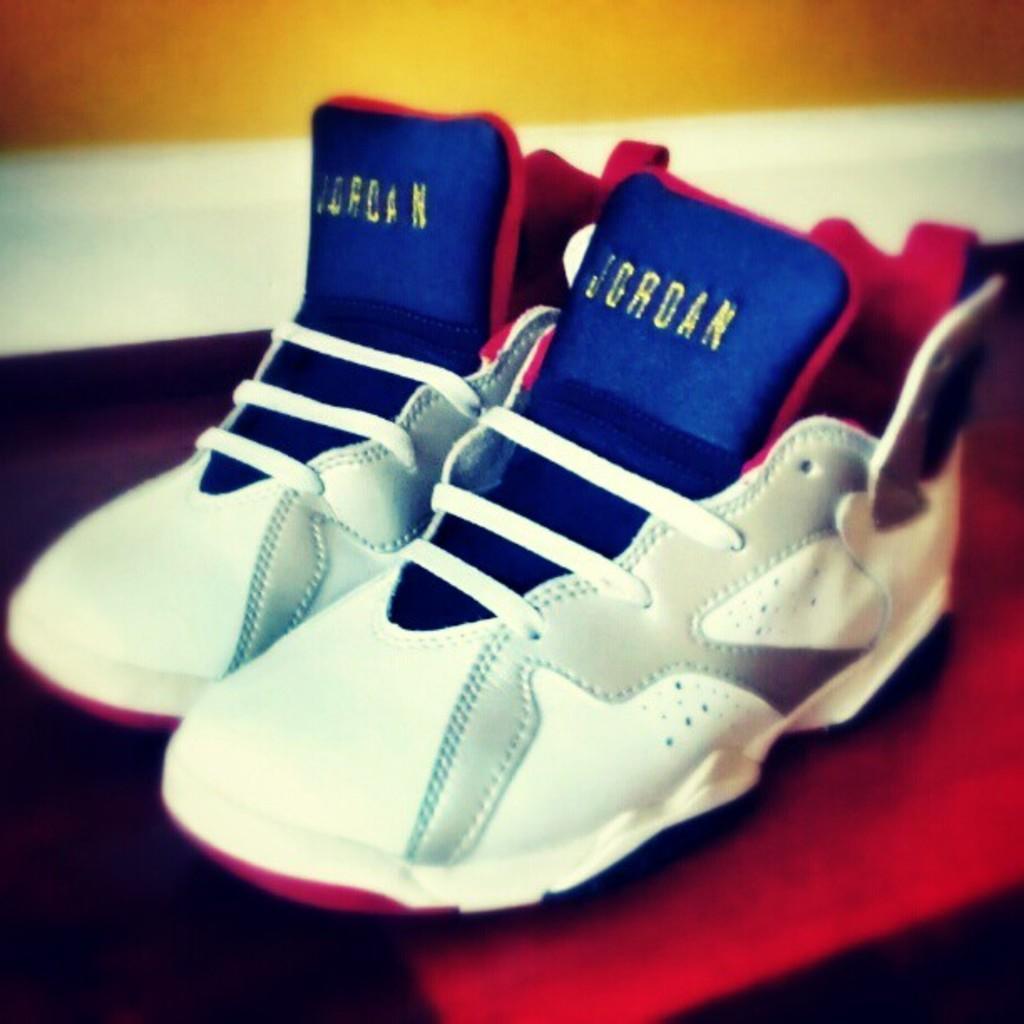How would you summarize this image in a sentence or two? In this image there are two shoes kept on the table one beside the other. In the background there is a wall. 